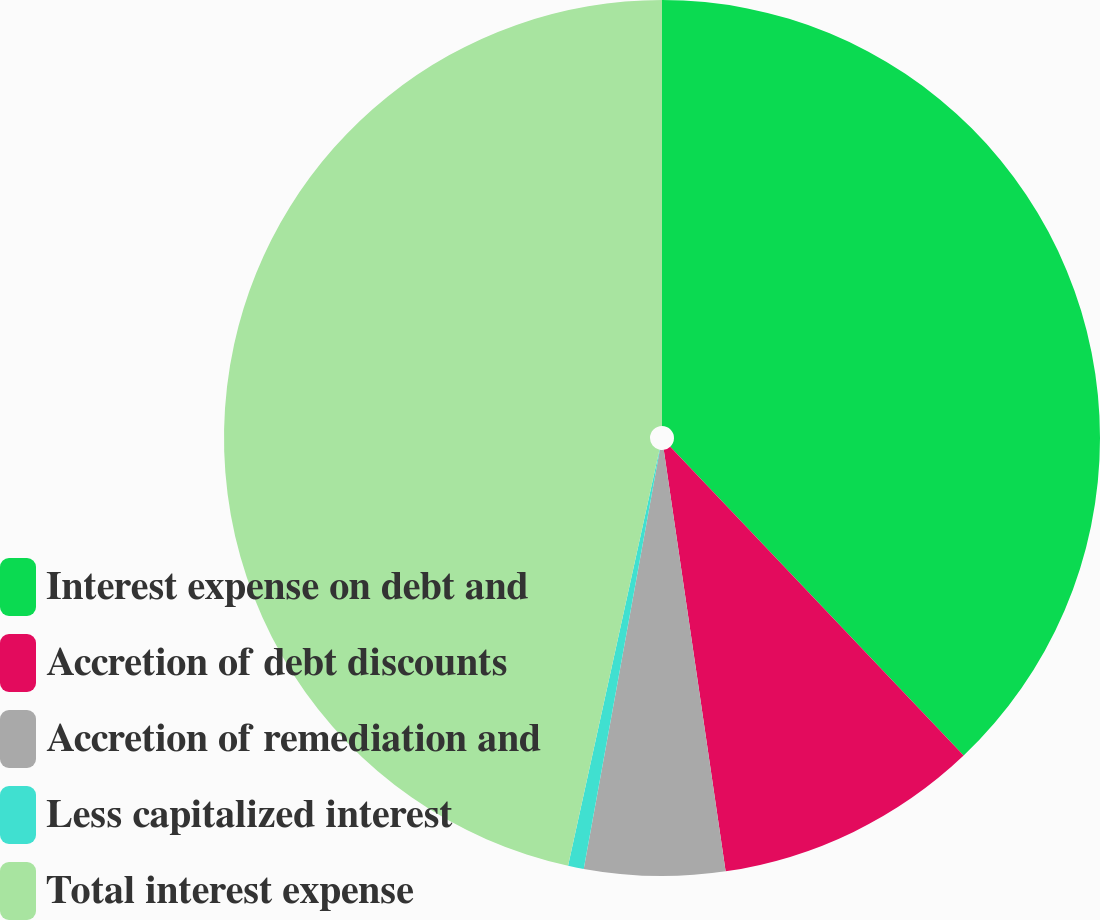Convert chart to OTSL. <chart><loc_0><loc_0><loc_500><loc_500><pie_chart><fcel>Interest expense on debt and<fcel>Accretion of debt discounts<fcel>Accretion of remediation and<fcel>Less capitalized interest<fcel>Total interest expense<nl><fcel>37.91%<fcel>9.77%<fcel>5.18%<fcel>0.58%<fcel>46.56%<nl></chart> 